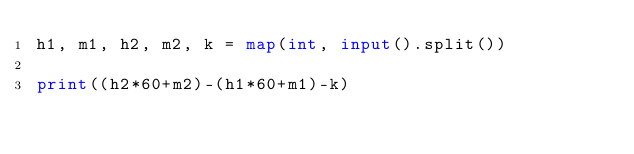<code> <loc_0><loc_0><loc_500><loc_500><_Python_>h1, m1, h2, m2, k = map(int, input().split())

print((h2*60+m2)-(h1*60+m1)-k)</code> 